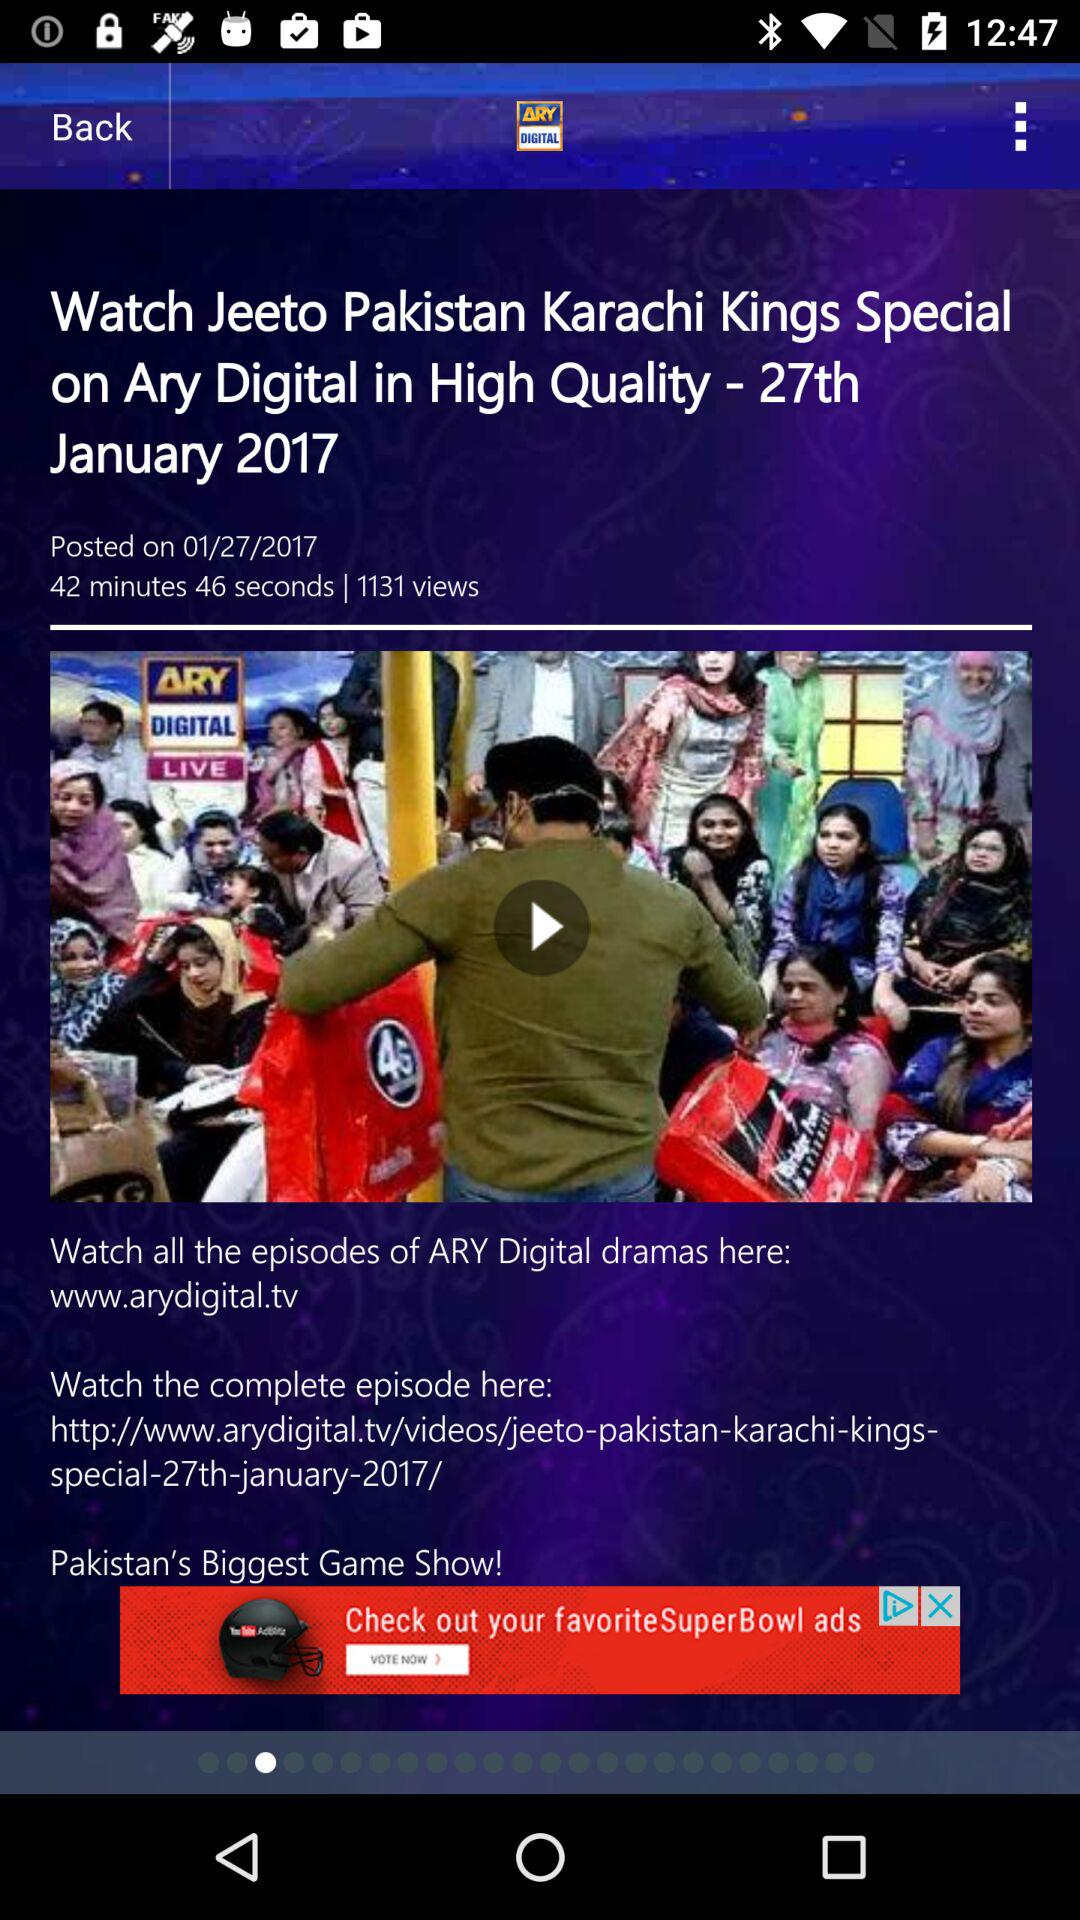What is the posting date and time of the drama named "Jeeto Pakistan Karachi Kings Special"? The posting date and time of the drama named "Jeeto Pakistan Karachi Kings Special" are January 27, 2017 and 42 minutes 46 seconds respectively. 